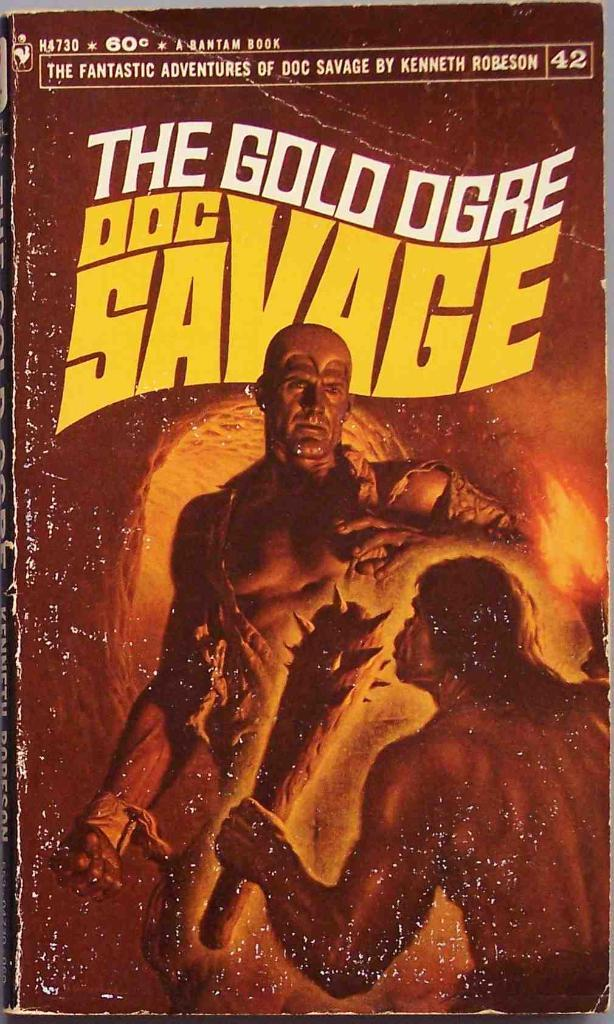<image>
Present a compact description of the photo's key features. A book with a giant and a cave man with a club called The Gold Ogre. 